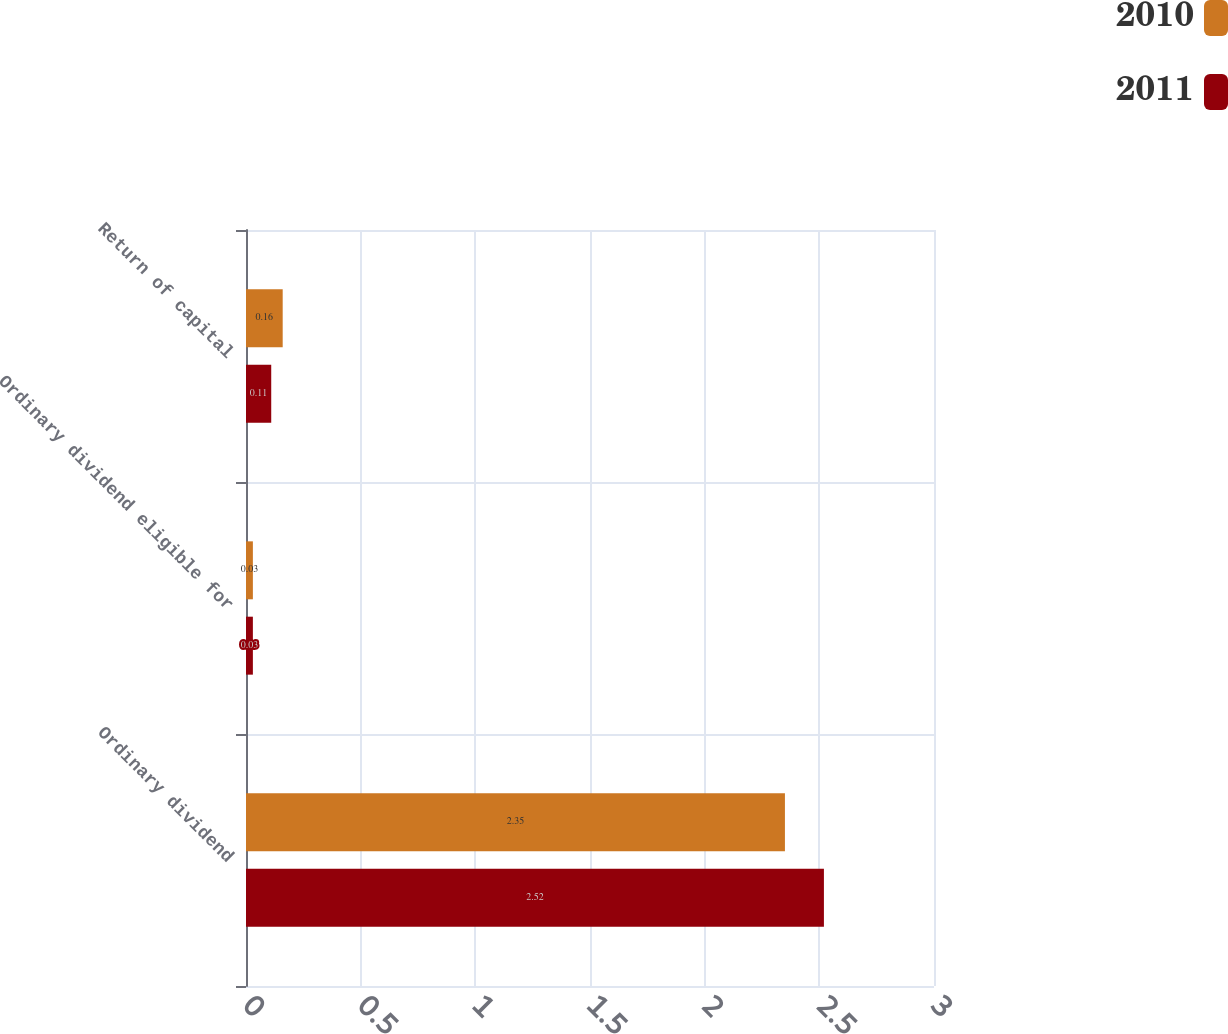<chart> <loc_0><loc_0><loc_500><loc_500><stacked_bar_chart><ecel><fcel>Ordinary dividend<fcel>Ordinary dividend eligible for<fcel>Return of capital<nl><fcel>2010<fcel>2.35<fcel>0.03<fcel>0.16<nl><fcel>2011<fcel>2.52<fcel>0.03<fcel>0.11<nl></chart> 